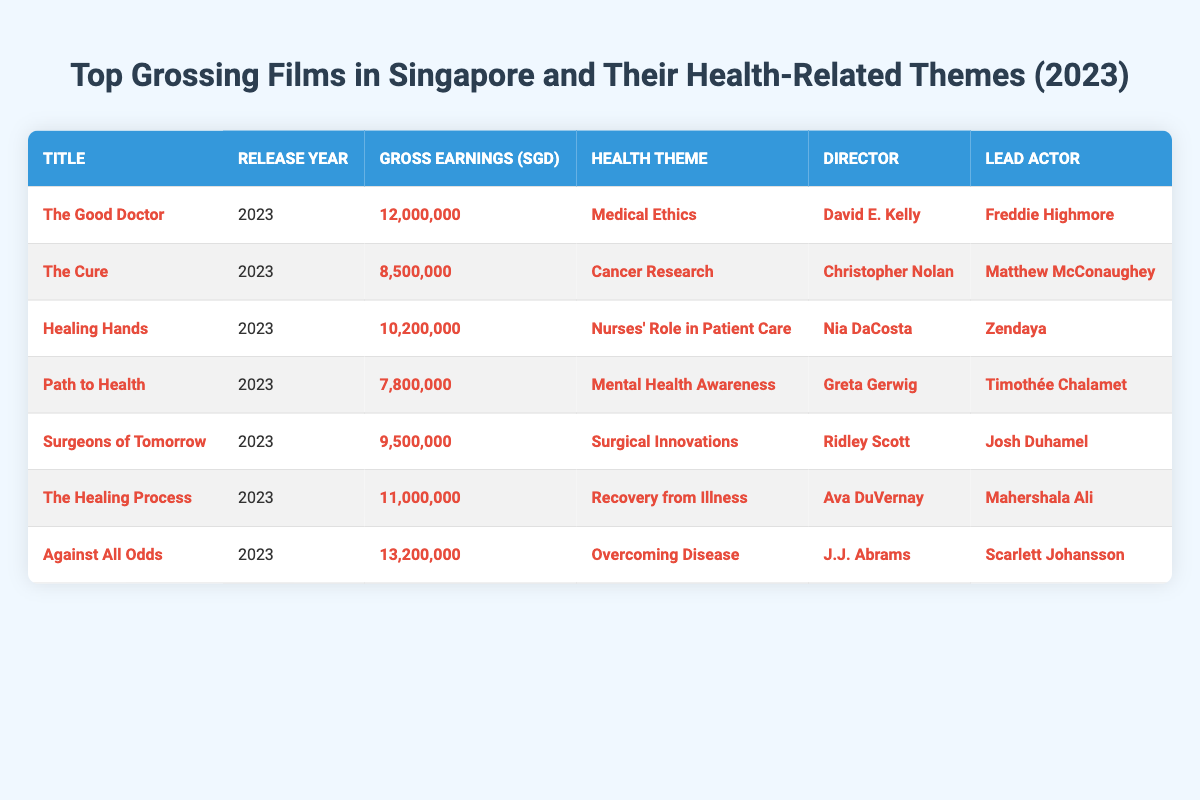What is the title of the film that grossed the highest earnings in Singapore in 2023? By examining the "Gross Earnings (SGD)" column, "**Against All Odds**" has the highest value of "**13,200,000**".
Answer: Against All Odds Who directed the film that addresses "Mental Health Awareness"? From the "Health Theme" column, we can identify "**Path to Health**" as the film related to "Mental Health Awareness", and its corresponding director is "**Greta Gerwig**".
Answer: Greta Gerwig Which film had gross earnings of SGD 10,200,000? The table shows that "**Healing Hands**" corresponds to the gross earnings of "**10,200,000**".
Answer: Healing Hands Is "Surgical Innovations" a health theme of any film on the list? Yes, by checking the "Health Theme" column, "**Surgeons of Tomorrow**" relates to "Surgical Innovations".
Answer: Yes What is the average gross earnings of the films that were released in 2023? Adding up the gross earnings: (12,000,000 + 8,500,000 + 10,200,000 + 7,800,000 + 9,500,000 + 11,000,000 + 13,200,000) = 82,200,000. Dividing this by the total number of films (7) gives an average of 82,200,000/7 ≈ 11,742,857.14.
Answer: Approximately 11,742,857 Which film features Mahershala Ali as the lead actor? The table indicates that "**The Healing Process**" has "**Mahershala Ali**" as its lead actor.
Answer: The Healing Process How many films focus on "Cancer Research"? From the "Health Theme" column, only one film, "**The Cure**", focuses on "Cancer Research".
Answer: One What is the total gross earnings of films with health themes related to nurses and recovery? From the table, "Healing Hands" (10,200,000) and "The Healing Process" (11,000,000) are related to nurses' roles and recovery respectively. The total earnings are 10,200,000 + 11,000,000 = 21,200,000.
Answer: 21,200,000 